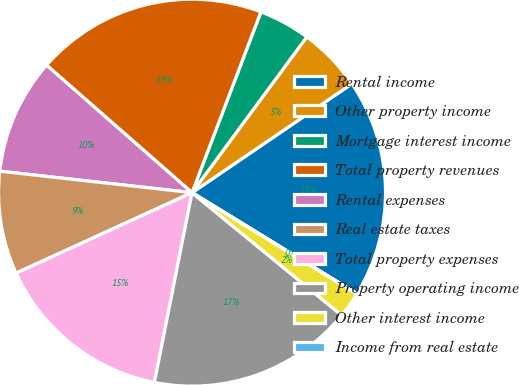Convert chart. <chart><loc_0><loc_0><loc_500><loc_500><pie_chart><fcel>Rental income<fcel>Other property income<fcel>Mortgage interest income<fcel>Total property revenues<fcel>Rental expenses<fcel>Real estate taxes<fcel>Total property expenses<fcel>Property operating income<fcel>Other interest income<fcel>Income from real estate<nl><fcel>18.27%<fcel>5.38%<fcel>4.31%<fcel>19.34%<fcel>9.68%<fcel>8.6%<fcel>15.05%<fcel>17.19%<fcel>2.16%<fcel>0.01%<nl></chart> 